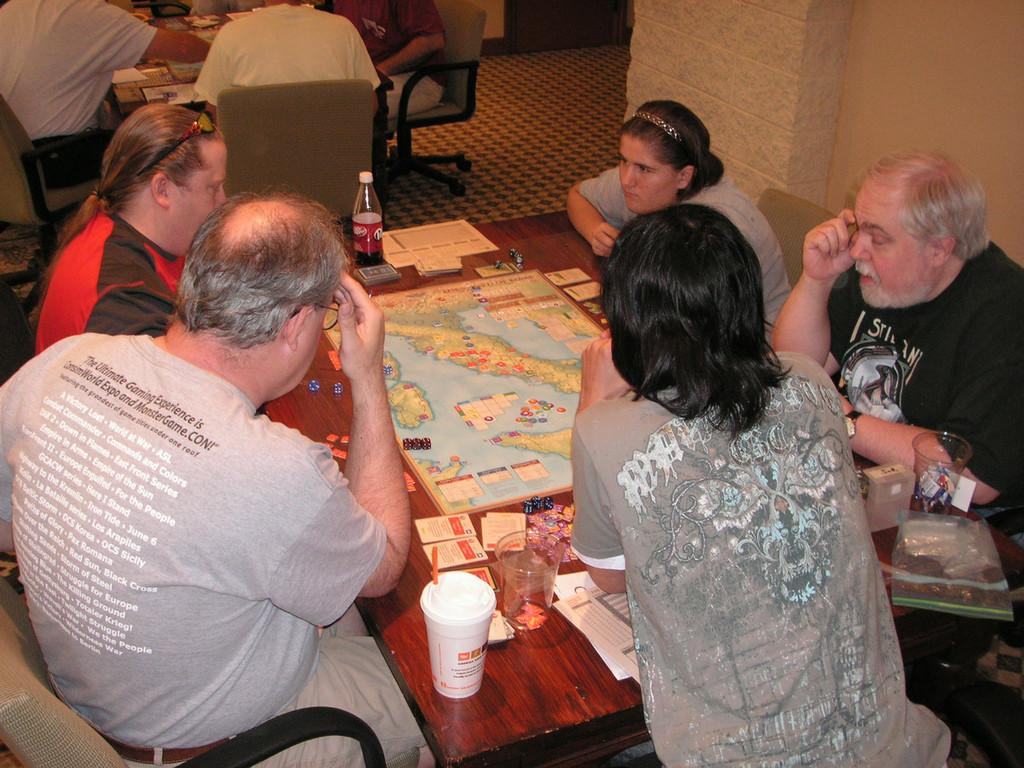What is happening in the image involving the group of people? The people in the image are seated on chairs. What objects are present on the table in the image? There are cups, a bottle, and a map on the table. What type of comb is being used by the spy in the image? There is no comb or spy present in the image. What kind of flowers are on the table in the image? There are no flowers present on the table in the image. 